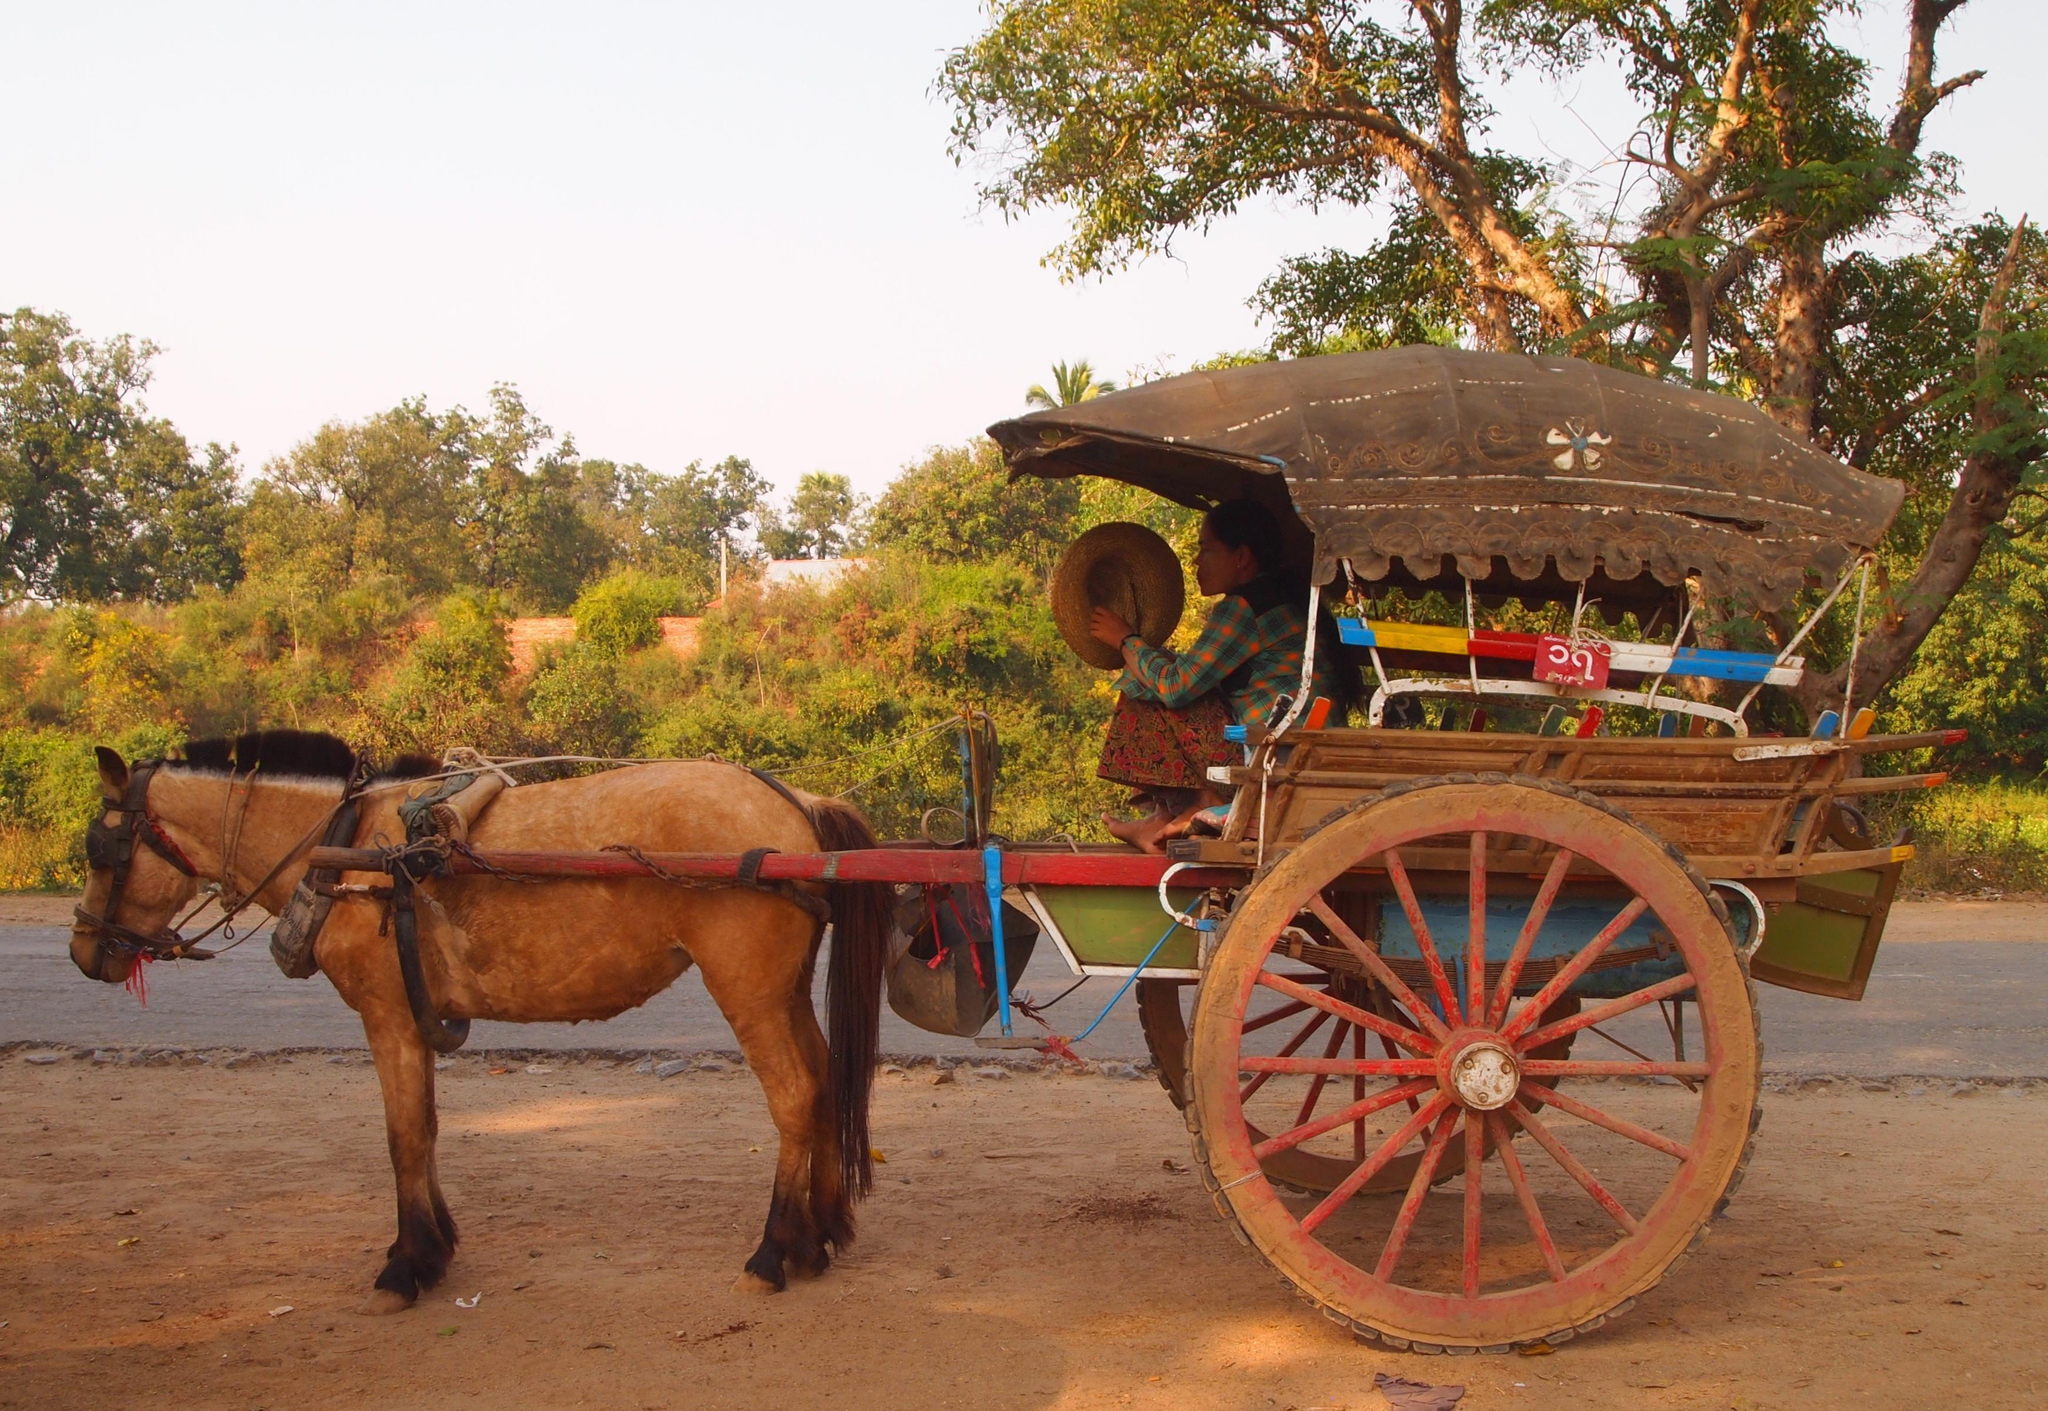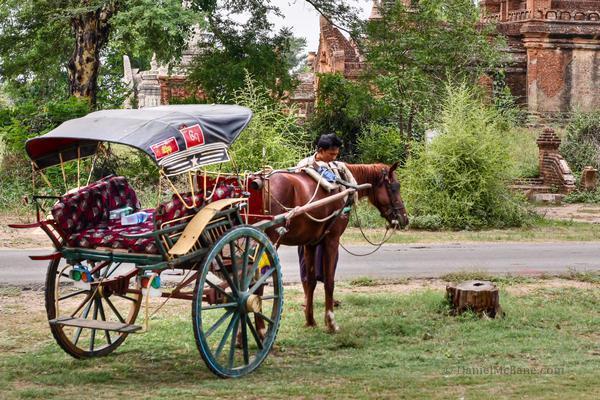The first image is the image on the left, the second image is the image on the right. Examine the images to the left and right. Is the description "Both of the carts are covered." accurate? Answer yes or no. Yes. 